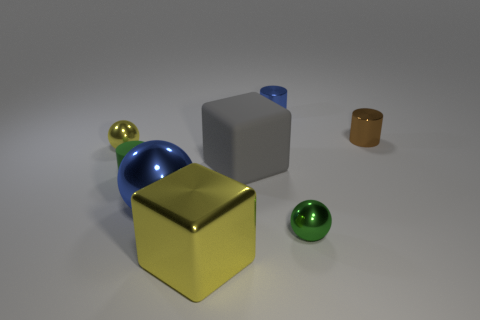Subtract all big blue metal balls. How many balls are left? 2 Subtract all blocks. How many objects are left? 6 Add 2 large green metallic blocks. How many objects exist? 10 Subtract 1 blocks. How many blocks are left? 1 Subtract all yellow balls. How many balls are left? 2 Subtract all purple blocks. Subtract all cyan balls. How many blocks are left? 2 Subtract all large blue balls. Subtract all tiny rubber cylinders. How many objects are left? 6 Add 8 tiny green matte cylinders. How many tiny green matte cylinders are left? 9 Add 8 large gray shiny objects. How many large gray shiny objects exist? 8 Subtract 0 green blocks. How many objects are left? 8 